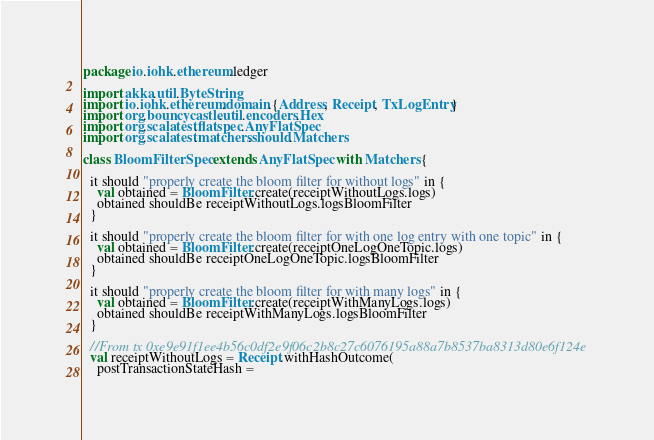Convert code to text. <code><loc_0><loc_0><loc_500><loc_500><_Scala_>package io.iohk.ethereum.ledger

import akka.util.ByteString
import io.iohk.ethereum.domain.{Address, Receipt, TxLogEntry}
import org.bouncycastle.util.encoders.Hex
import org.scalatest.flatspec.AnyFlatSpec
import org.scalatest.matchers.should.Matchers

class BloomFilterSpec extends AnyFlatSpec with Matchers {

  it should "properly create the bloom filter for without logs" in {
    val obtained = BloomFilter.create(receiptWithoutLogs.logs)
    obtained shouldBe receiptWithoutLogs.logsBloomFilter
  }

  it should "properly create the bloom filter for with one log entry with one topic" in {
    val obtained = BloomFilter.create(receiptOneLogOneTopic.logs)
    obtained shouldBe receiptOneLogOneTopic.logsBloomFilter
  }

  it should "properly create the bloom filter for with many logs" in {
    val obtained = BloomFilter.create(receiptWithManyLogs.logs)
    obtained shouldBe receiptWithManyLogs.logsBloomFilter
  }

  //From tx 0xe9e91f1ee4b56c0df2e9f06c2b8c27c6076195a88a7b8537ba8313d80e6f124e
  val receiptWithoutLogs = Receipt.withHashOutcome(
    postTransactionStateHash =</code> 